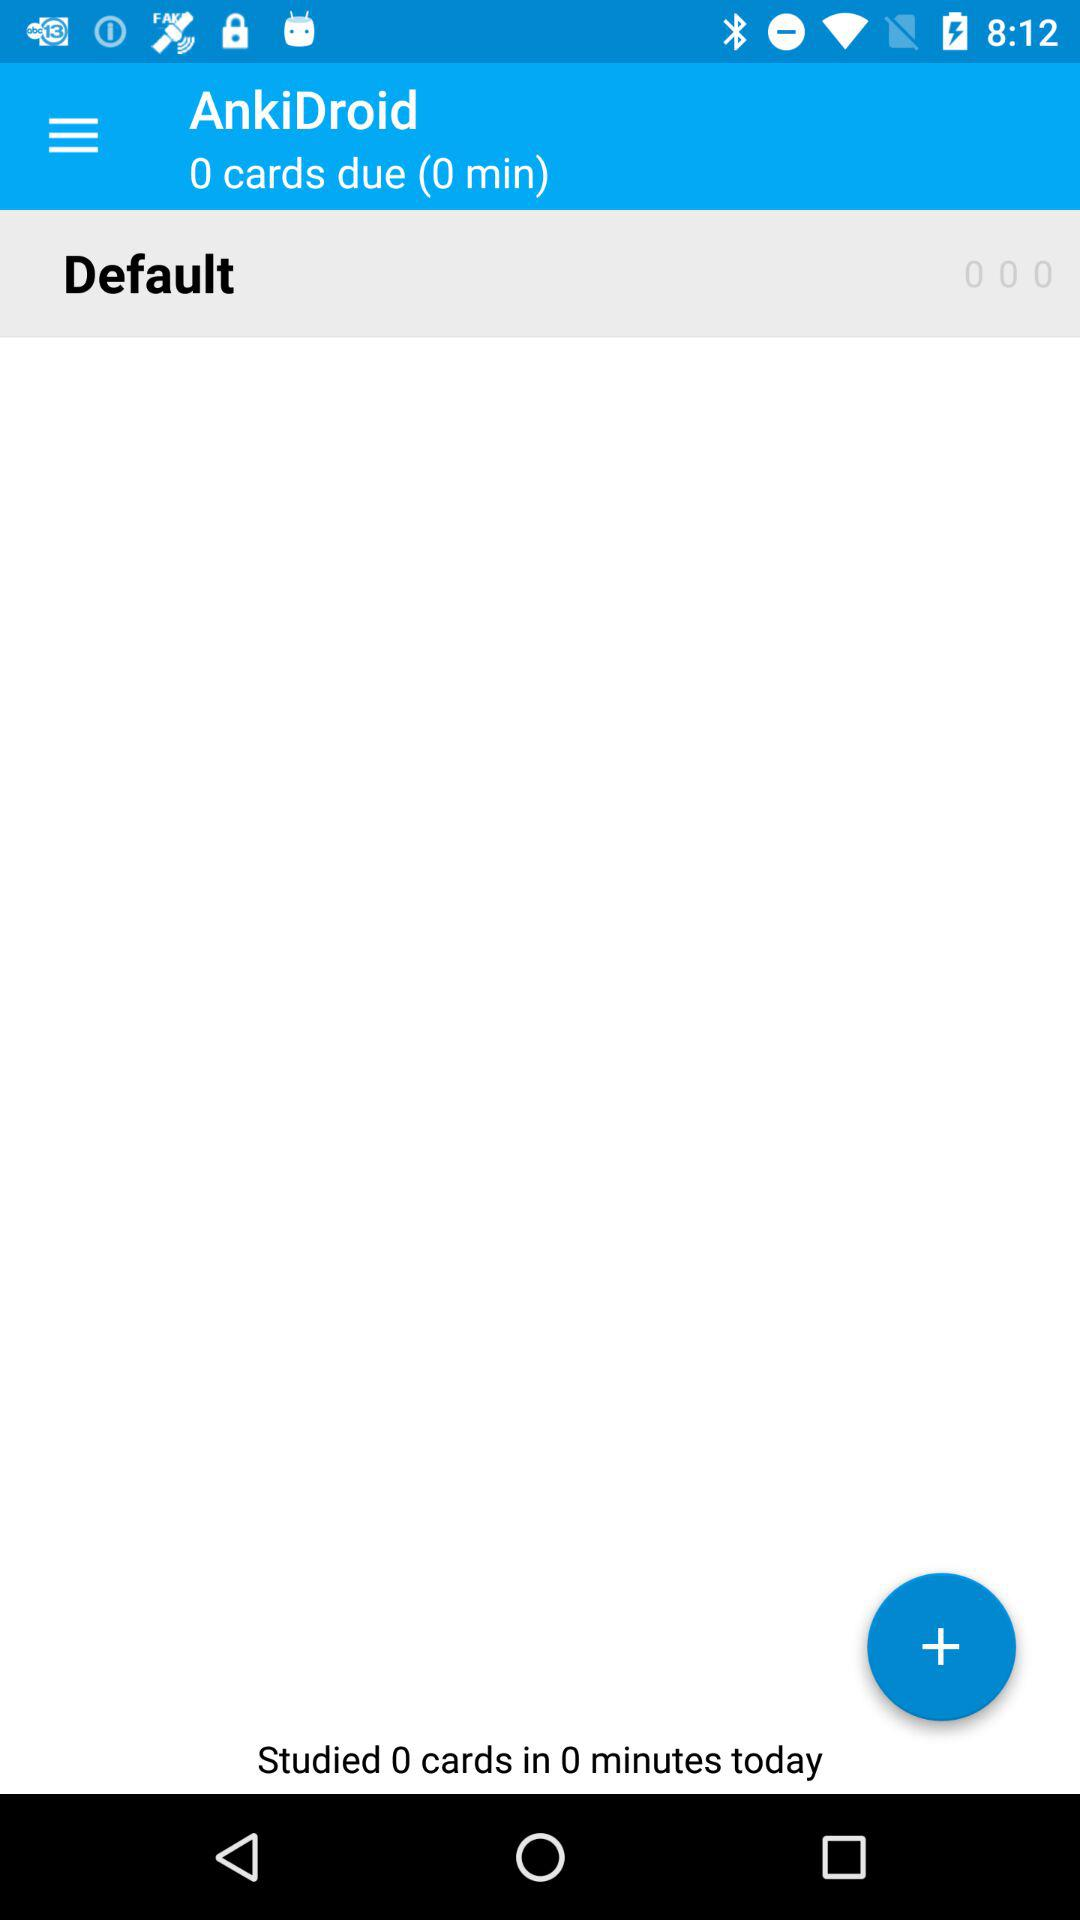What is the number of cards studied in 0 minutes today? The number of cards studied today is 0. 